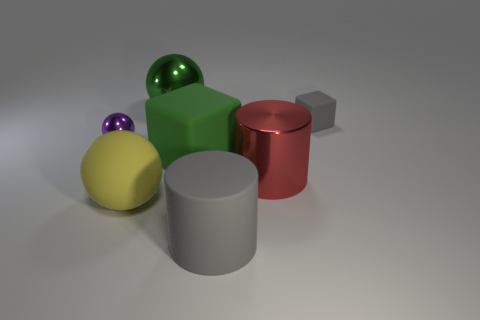Add 3 big things. How many objects exist? 10 Subtract all cylinders. How many objects are left? 5 Subtract 0 red spheres. How many objects are left? 7 Subtract all rubber spheres. Subtract all red metallic cylinders. How many objects are left? 5 Add 4 spheres. How many spheres are left? 7 Add 1 large yellow matte cylinders. How many large yellow matte cylinders exist? 1 